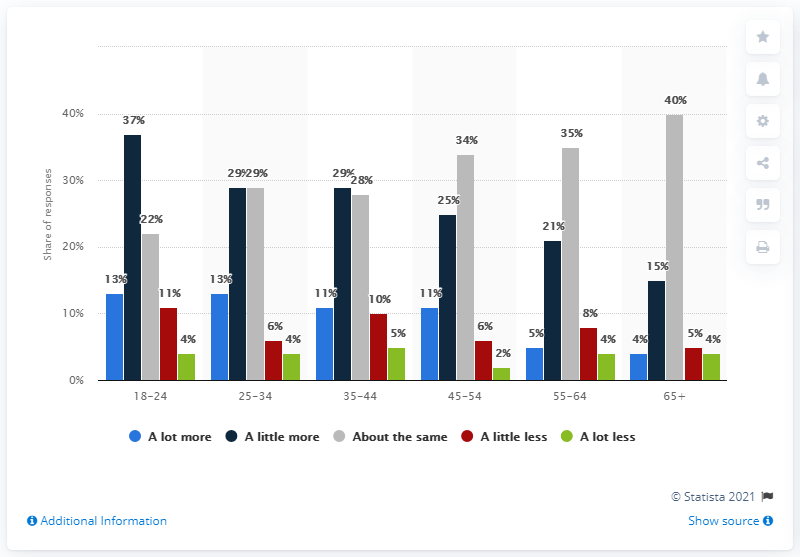Identify some key points in this picture. According to the data provided, 40% of people over the age of 65 reported that their consumption was the same as usual. 